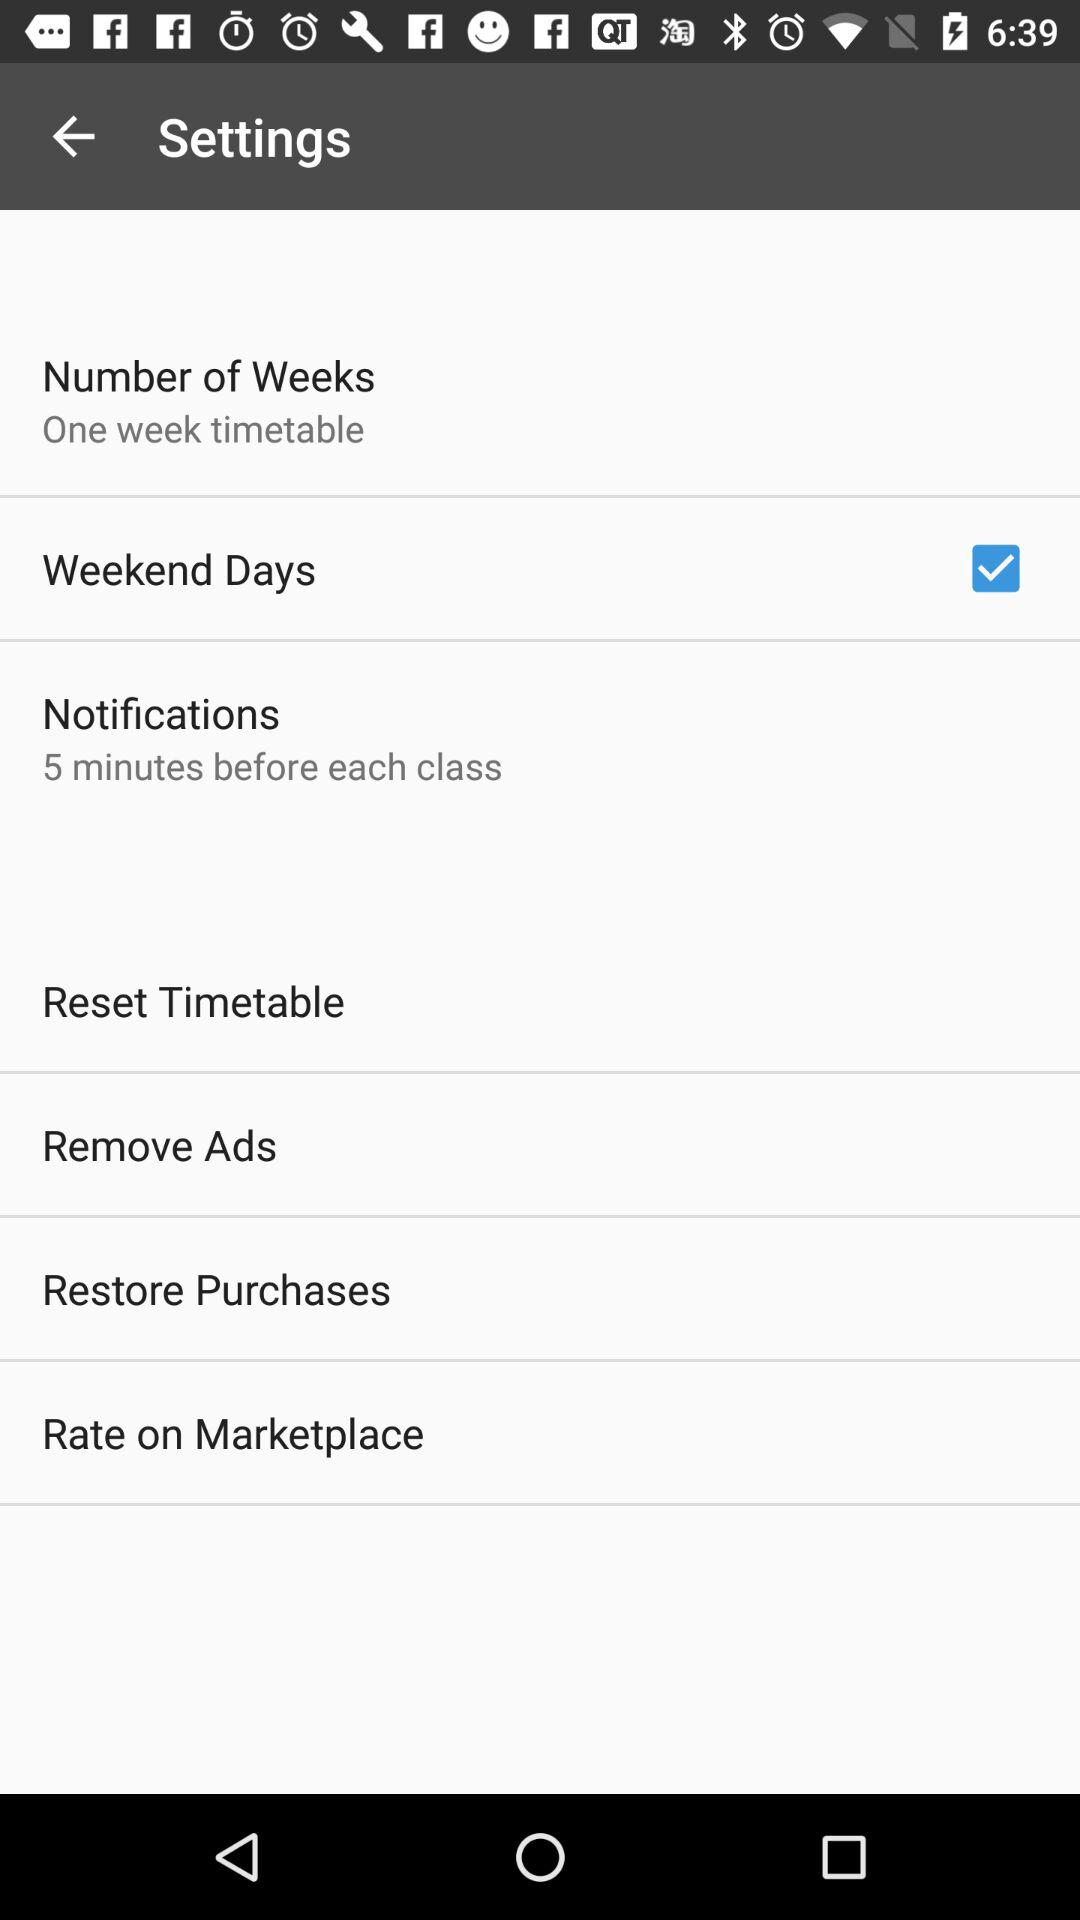How many weeks is the time table formed for? The time table is formed for one week. 